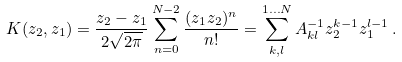Convert formula to latex. <formula><loc_0><loc_0><loc_500><loc_500>K ( z _ { 2 } , z _ { 1 } ) = \frac { z _ { 2 } - z _ { 1 } } { 2 \sqrt { 2 \pi } } \sum _ { n = 0 } ^ { N - 2 } \frac { ( z _ { 1 } z _ { 2 } ) ^ { n } } { n ! } = \sum _ { k , l } ^ { 1 \dots N } A _ { k l } ^ { - 1 } z _ { 2 } ^ { k - 1 } z _ { 1 } ^ { l - 1 } \, .</formula> 